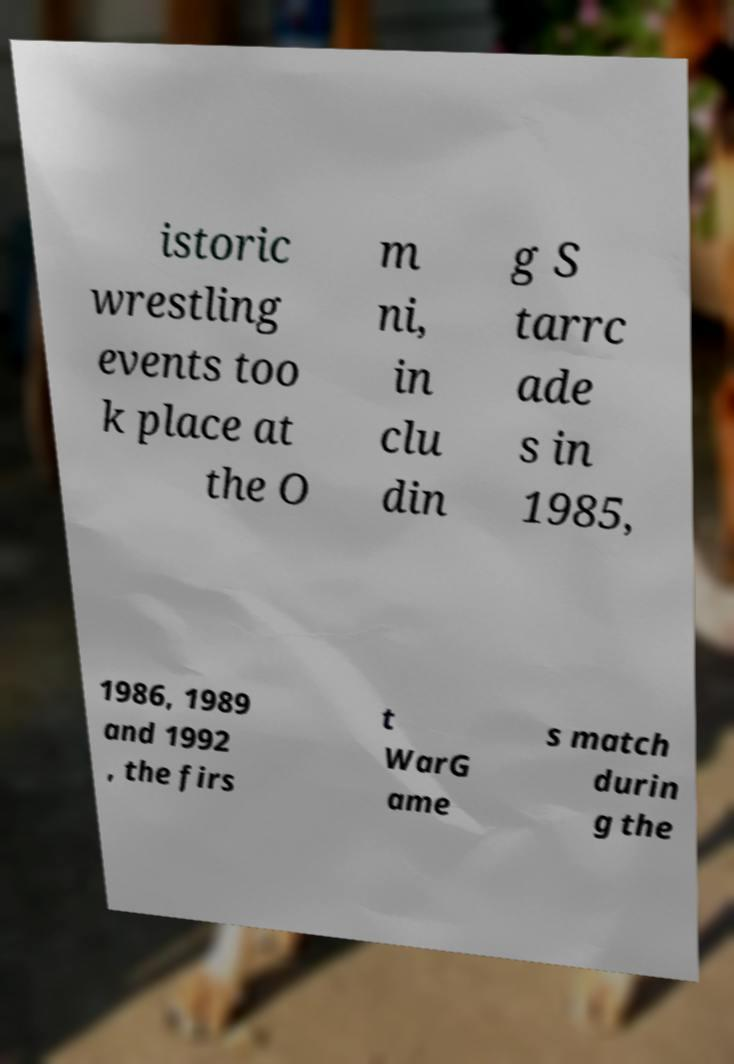Can you accurately transcribe the text from the provided image for me? istoric wrestling events too k place at the O m ni, in clu din g S tarrc ade s in 1985, 1986, 1989 and 1992 , the firs t WarG ame s match durin g the 